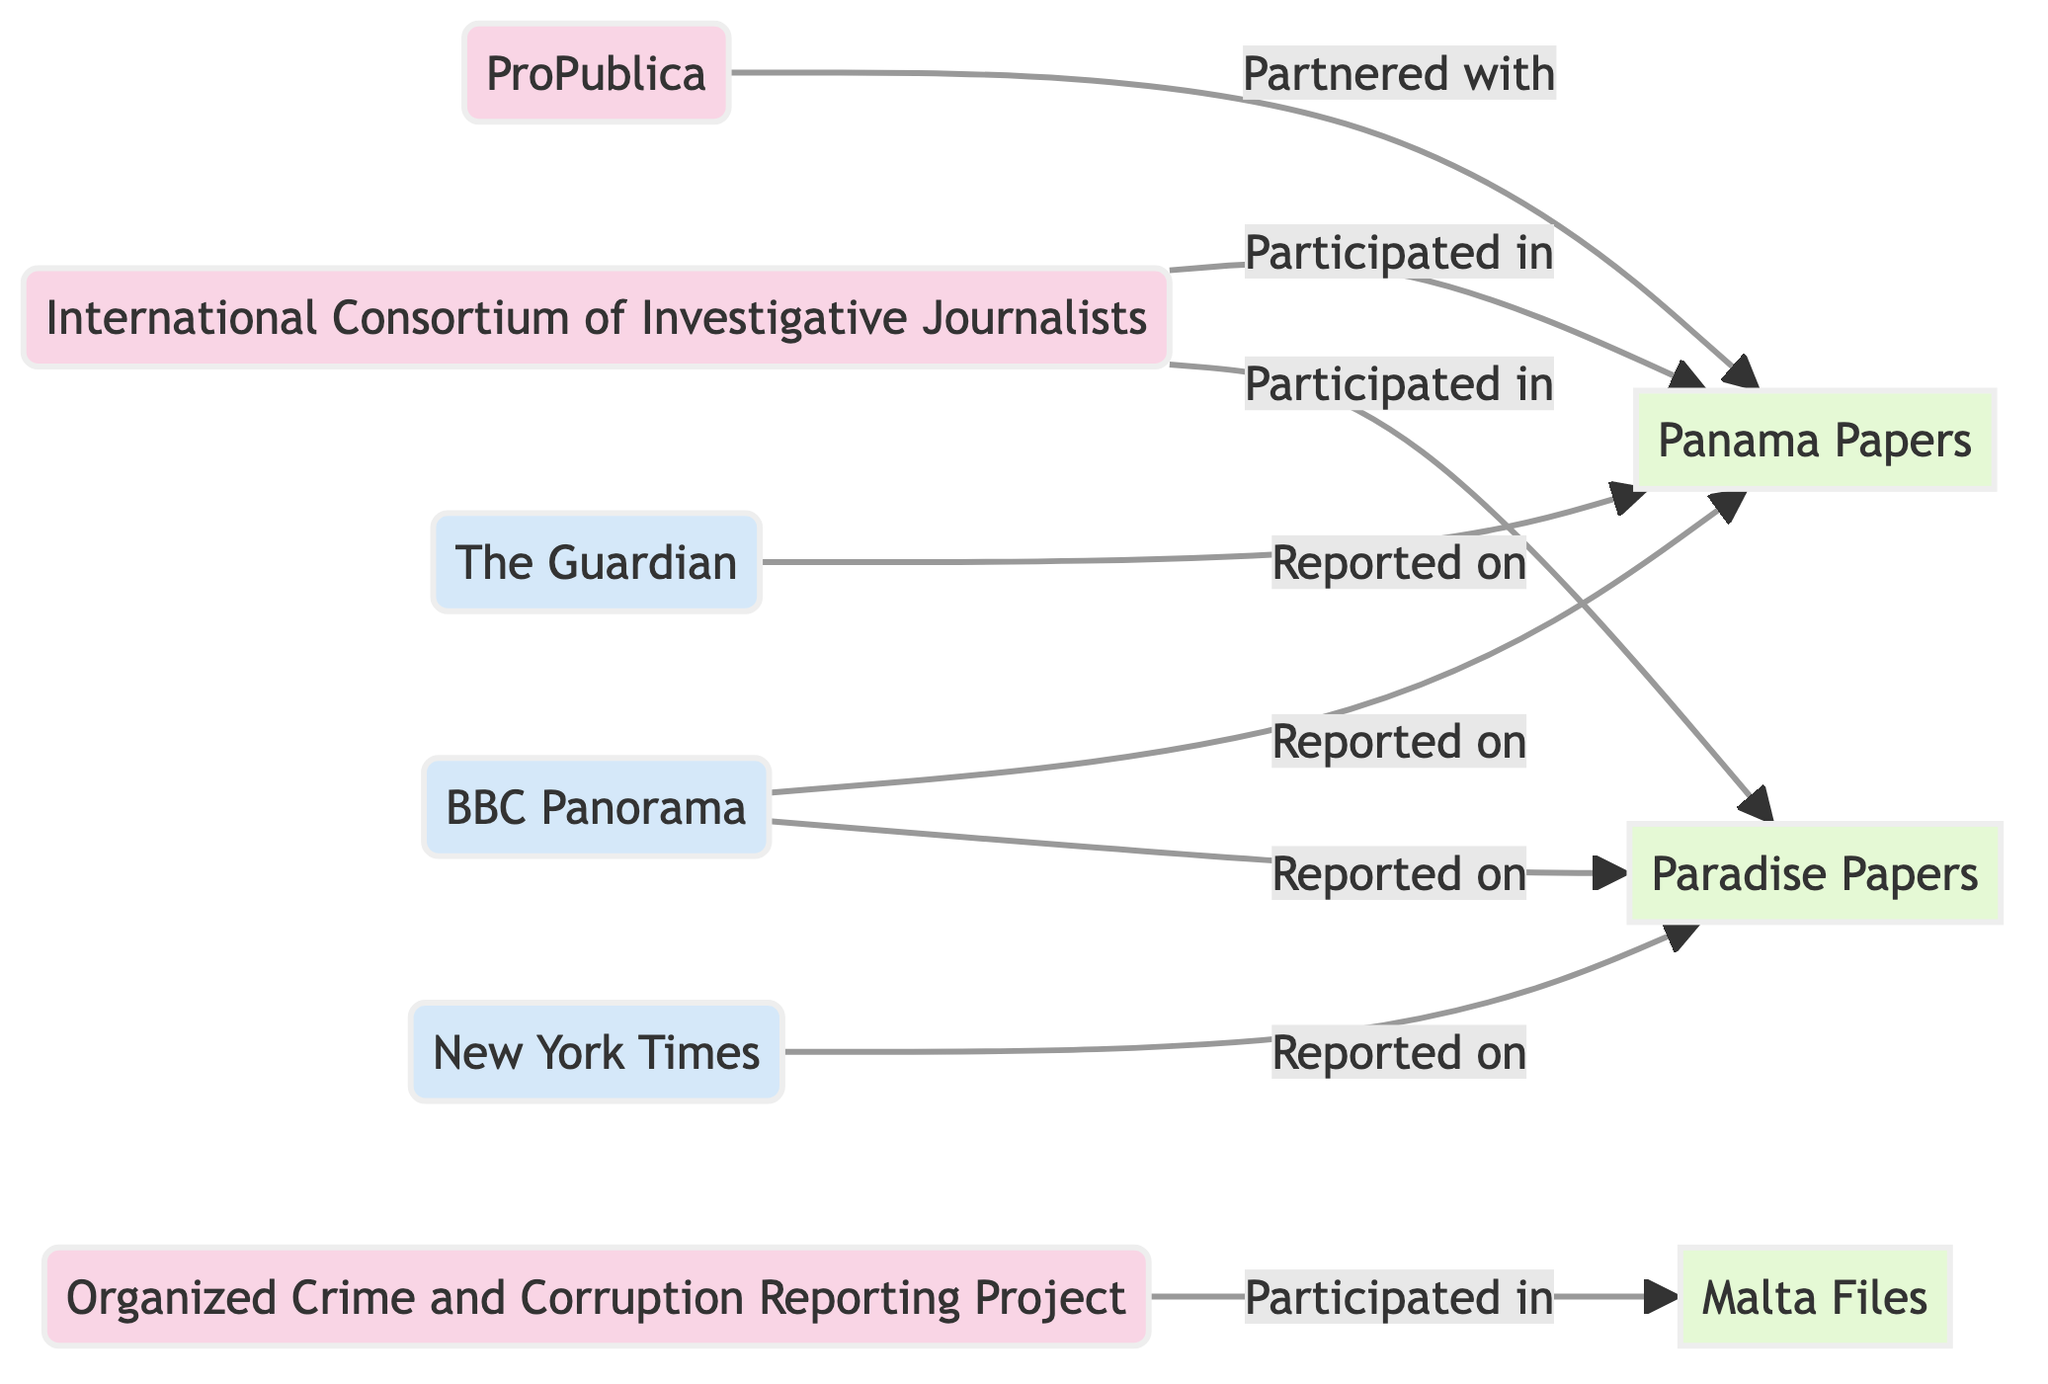What are the total number of organizations in the diagram? The diagram lists three organizations: International Consortium of Investigative Journalists, Organized Crime and Corruption Reporting Project, and ProPublica. Counting these nodes gives us a total of three organizations.
Answer: 3 Which projects did the International Consortium of Investigative Journalists participate in? The diagram shows links from International Consortium of Investigative Journalists to two projects: Panama Papers and Paradise Papers.
Answer: Panama Papers, Paradise Papers How many media outlets are involved in reporting on the Paradise Papers? The diagram indicates two media outlets reporting on the Paradise Papers: New York Times and BBC Panorama. Thus, the count of media outlets involved is two.
Answer: 2 What type of relationship does ProPublica have with the Panama Papers project? In the diagram, the link from ProPublica to Panama Papers is labeled as "Partnered with," indicating a collaborative relationship between ProPublica and the project.
Answer: Partnered with Which project is reported on by the Guardian? The Guardian is linked to the Panama Papers in the diagram with a relationship labeled "Reported on," indicating their involvement in the coverage of this project.
Answer: Panama Papers Which organization is linked to the Malta Files? The diagram shows that the Organized Crime and Corruption Reporting Project has a link to the Malta Files, indicating their participation in this project.
Answer: Organized Crime and Corruption Reporting Project How many total links connect organizations to projects in the diagram? By counting the links, we find that there are six connections: two from International Consortium of Investigative Journalists, one from Organized Crime and Corruption Reporting Project, and three involving media outlets reporting on the projects. The total is six links.
Answer: 6 What are the two projects associated with the BBC? The diagram shows that the BBC links to two projects: Panama Papers and Paradise Papers, indicating they reported on both.
Answer: Panama Papers, Paradise Papers Which media outlet is associated with both the Panama Papers and Paradise Papers projects? The diagram indicates that BBC Panorama is linked to both projects; therefore, it is the media outlet associated with both the Panama Papers and Paradise Papers.
Answer: BBC Panorama 